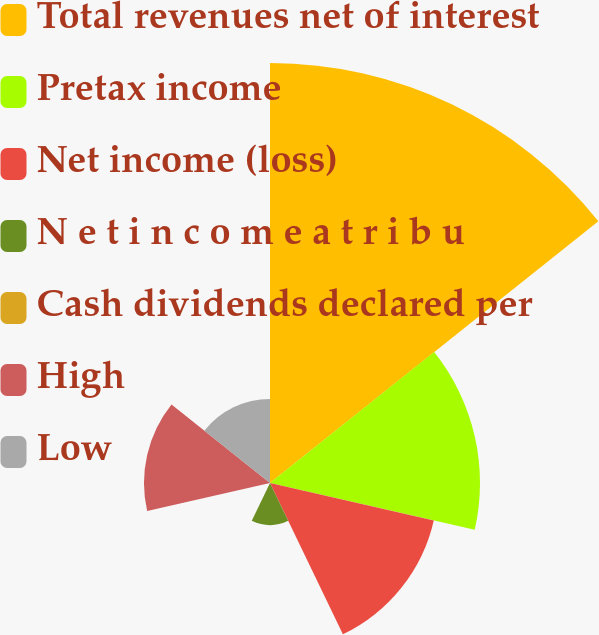Convert chart to OTSL. <chart><loc_0><loc_0><loc_500><loc_500><pie_chart><fcel>Total revenues net of interest<fcel>Pretax income<fcel>Net income (loss)<fcel>N e t i n c o m e a t r i b u<fcel>Cash dividends declared per<fcel>High<fcel>Low<nl><fcel>40.0%<fcel>20.0%<fcel>16.0%<fcel>4.0%<fcel>0.0%<fcel>12.0%<fcel>8.0%<nl></chart> 